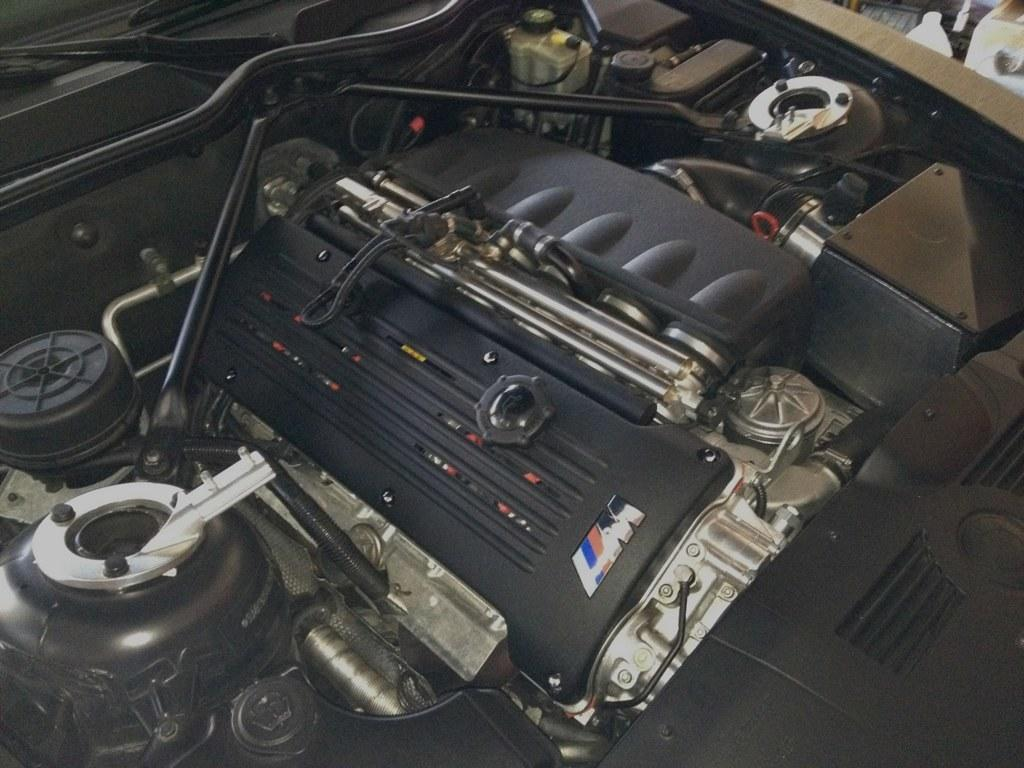What is the main subject of the image? The main subject of the image is an engine of a vehicle. Can you describe the engine in more detail? Unfortunately, the image only shows the engine, and no further details are provided. What type of vehicle might this engine belong to? Without additional information, it is impossible to determine the type of vehicle the engine belongs to. How many zippers can be seen on the engine in the image? There are no zippers present on the engine in the image, as they are not related to engines or vehicles. 